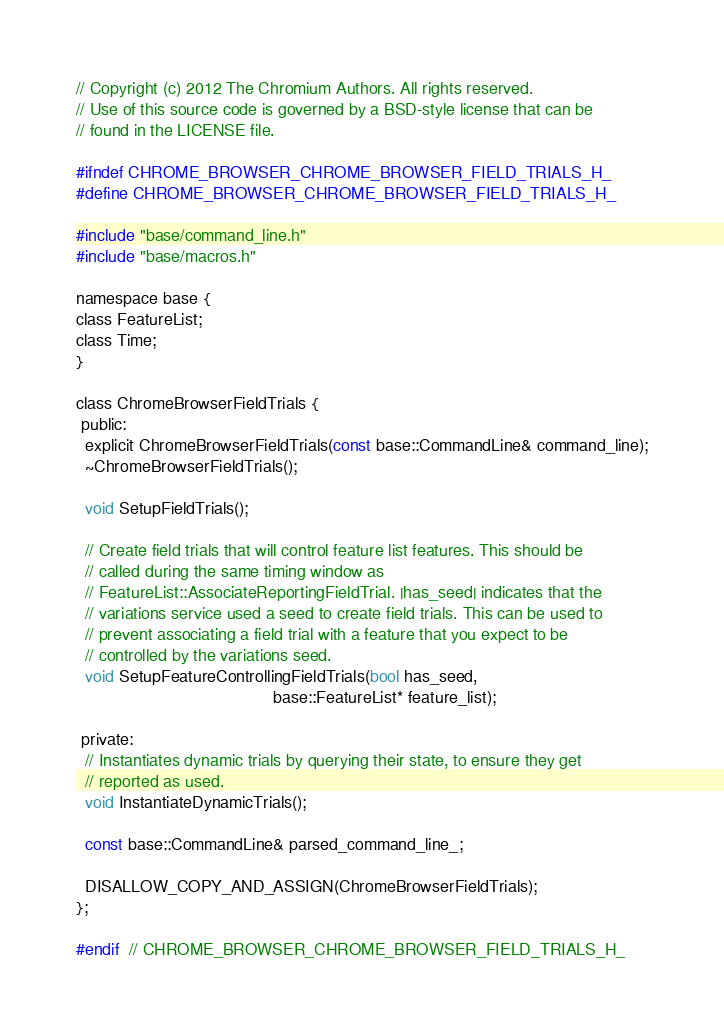Convert code to text. <code><loc_0><loc_0><loc_500><loc_500><_C_>// Copyright (c) 2012 The Chromium Authors. All rights reserved.
// Use of this source code is governed by a BSD-style license that can be
// found in the LICENSE file.

#ifndef CHROME_BROWSER_CHROME_BROWSER_FIELD_TRIALS_H_
#define CHROME_BROWSER_CHROME_BROWSER_FIELD_TRIALS_H_

#include "base/command_line.h"
#include "base/macros.h"

namespace base {
class FeatureList;
class Time;
}

class ChromeBrowserFieldTrials {
 public:
  explicit ChromeBrowserFieldTrials(const base::CommandLine& command_line);
  ~ChromeBrowserFieldTrials();

  void SetupFieldTrials();

  // Create field trials that will control feature list features. This should be
  // called during the same timing window as
  // FeatureList::AssociateReportingFieldTrial. |has_seed| indicates that the
  // variations service used a seed to create field trials. This can be used to
  // prevent associating a field trial with a feature that you expect to be
  // controlled by the variations seed.
  void SetupFeatureControllingFieldTrials(bool has_seed,
                                          base::FeatureList* feature_list);

 private:
  // Instantiates dynamic trials by querying their state, to ensure they get
  // reported as used.
  void InstantiateDynamicTrials();

  const base::CommandLine& parsed_command_line_;

  DISALLOW_COPY_AND_ASSIGN(ChromeBrowserFieldTrials);
};

#endif  // CHROME_BROWSER_CHROME_BROWSER_FIELD_TRIALS_H_
</code> 